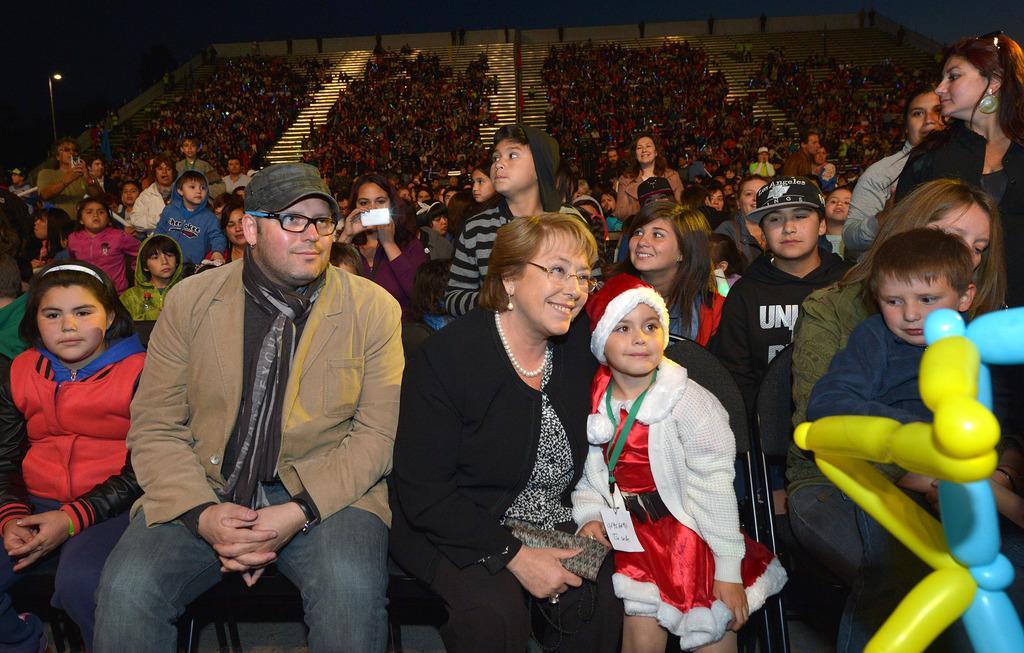Can you describe this image briefly? In the center of the image there are people sitting on chairs. In the background of the image there are people sitting in stands. 